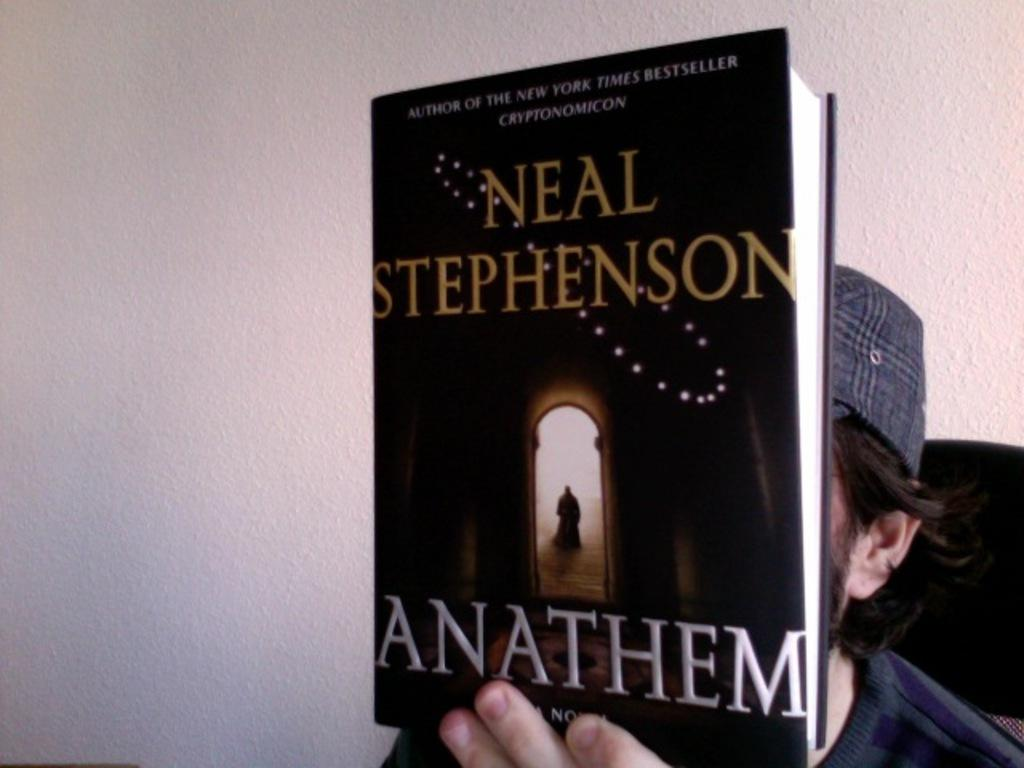What is the man in the image doing? The man is sitting in the image. What is the man holding in the image? The man is holding a book in the image. Can you describe the book in the image? The book has text on it. What is visible on the backside of the image? There is a wall visible on the backside of the image. What type of truck can be seen in the frame of the image? There is no truck present in the image; it only features a man sitting and holding a book. 